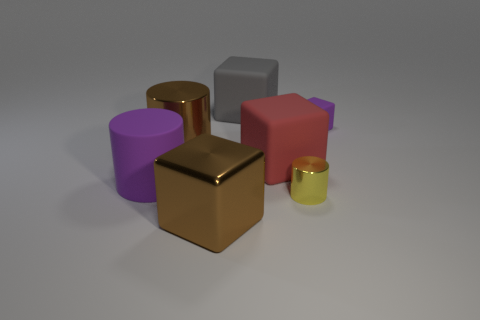How big is the brown cylinder?
Ensure brevity in your answer.  Large. There is a big thing that is the same color as the metal cube; what shape is it?
Keep it short and to the point. Cylinder. Is the number of big cylinders greater than the number of tiny green matte balls?
Offer a very short reply. Yes. There is a metallic cylinder that is in front of the purple rubber object to the left of the brown thing that is in front of the brown metal cylinder; what is its color?
Offer a very short reply. Yellow. Is the shape of the metallic thing that is behind the small metallic cylinder the same as  the small matte object?
Provide a succinct answer. No. The other cylinder that is the same size as the brown metallic cylinder is what color?
Provide a short and direct response. Purple. How many brown things are there?
Your answer should be very brief. 2. Is the yellow cylinder in front of the large red matte thing made of the same material as the purple cylinder?
Provide a short and direct response. No. What is the cube that is both in front of the purple cube and behind the rubber cylinder made of?
Offer a terse response. Rubber. There is a object that is the same color as the big metallic cylinder; what size is it?
Provide a succinct answer. Large. 